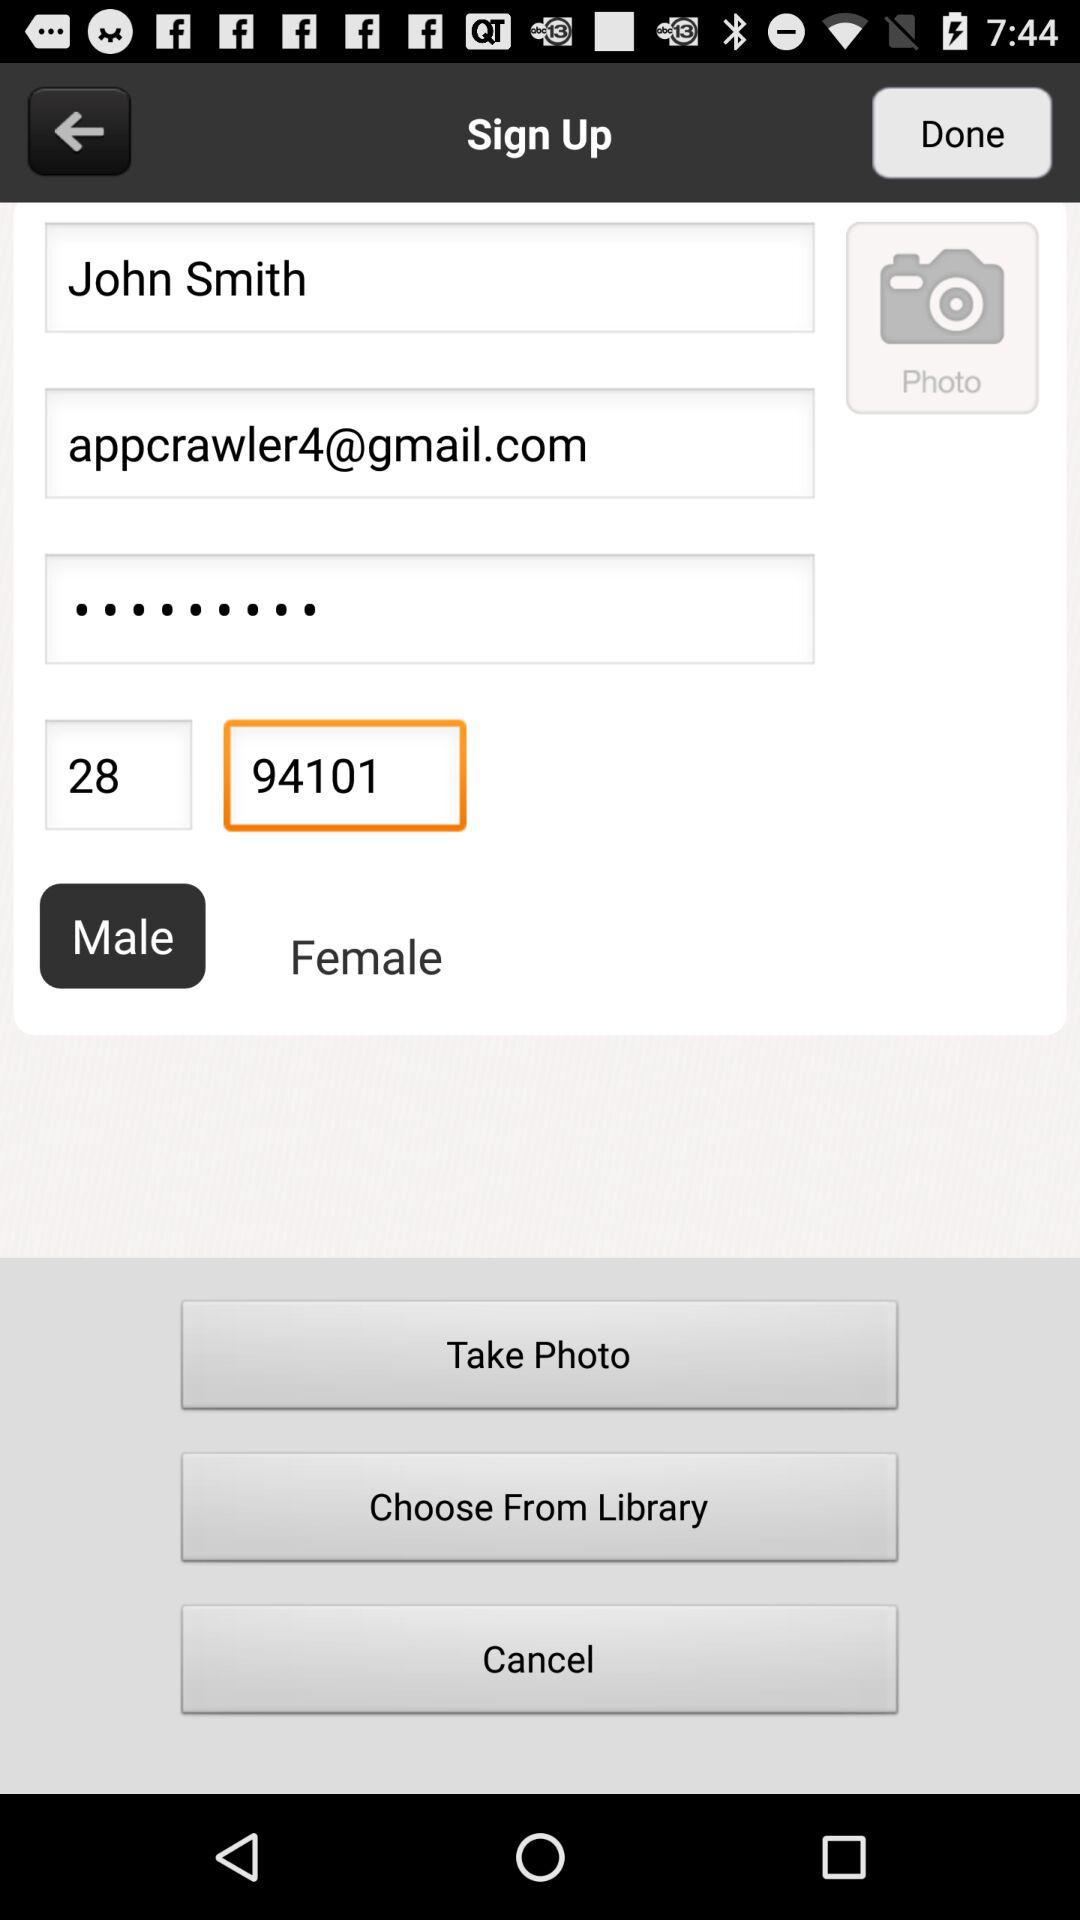What is the user name? The user name is John Smith. 